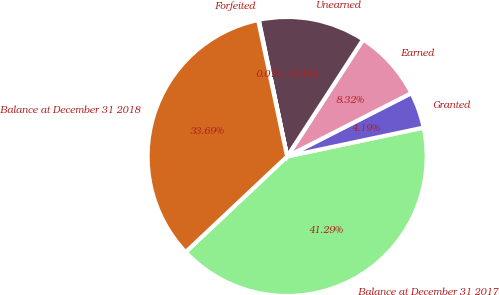<chart> <loc_0><loc_0><loc_500><loc_500><pie_chart><fcel>Balance at December 31 2017<fcel>Granted<fcel>Earned<fcel>Unearned<fcel>Forfeited<fcel>Balance at December 31 2018<nl><fcel>41.29%<fcel>4.19%<fcel>8.32%<fcel>12.44%<fcel>0.07%<fcel>33.69%<nl></chart> 